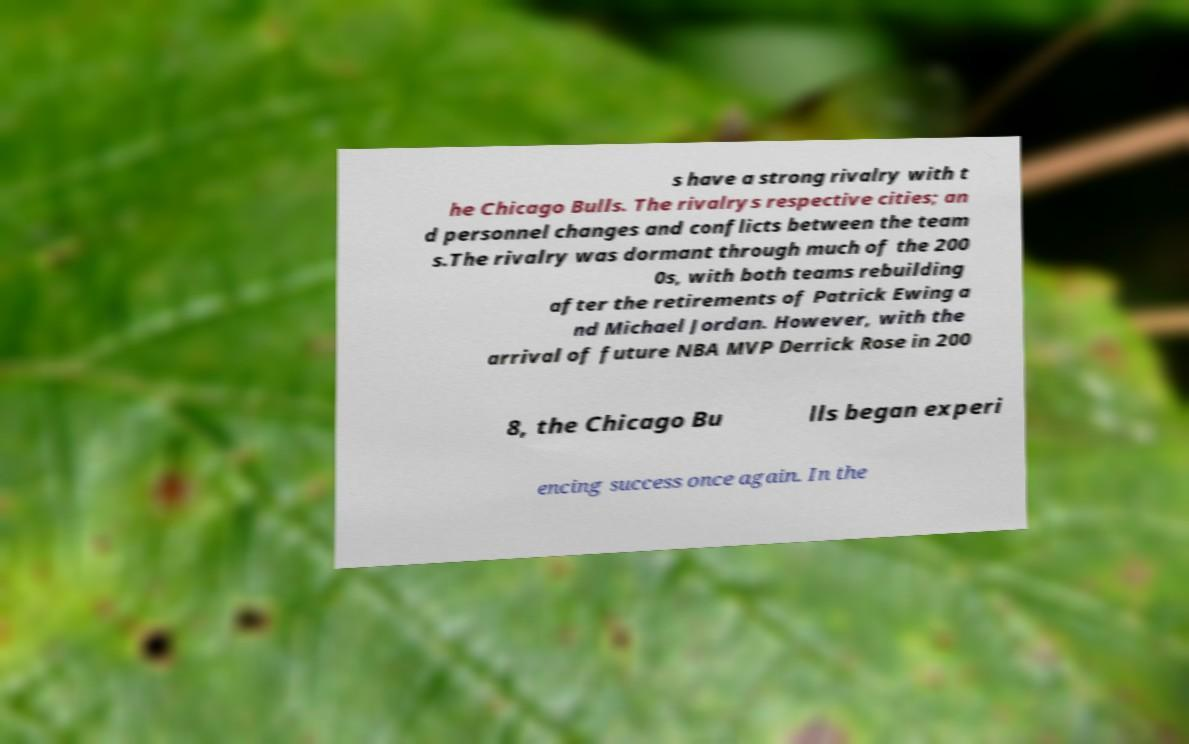There's text embedded in this image that I need extracted. Can you transcribe it verbatim? s have a strong rivalry with t he Chicago Bulls. The rivalrys respective cities; an d personnel changes and conflicts between the team s.The rivalry was dormant through much of the 200 0s, with both teams rebuilding after the retirements of Patrick Ewing a nd Michael Jordan. However, with the arrival of future NBA MVP Derrick Rose in 200 8, the Chicago Bu lls began experi encing success once again. In the 